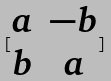<formula> <loc_0><loc_0><loc_500><loc_500>[ \begin{matrix} a & - b \\ b & a \end{matrix} ]</formula> 